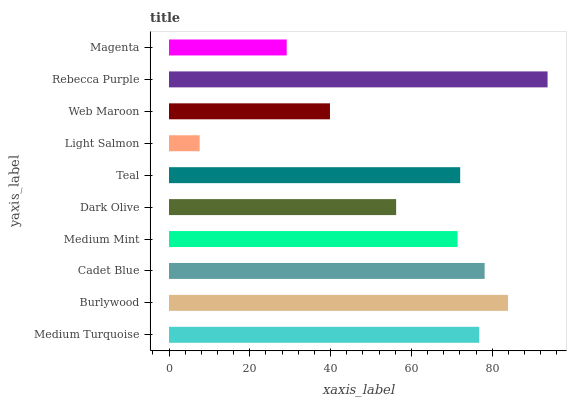Is Light Salmon the minimum?
Answer yes or no. Yes. Is Rebecca Purple the maximum?
Answer yes or no. Yes. Is Burlywood the minimum?
Answer yes or no. No. Is Burlywood the maximum?
Answer yes or no. No. Is Burlywood greater than Medium Turquoise?
Answer yes or no. Yes. Is Medium Turquoise less than Burlywood?
Answer yes or no. Yes. Is Medium Turquoise greater than Burlywood?
Answer yes or no. No. Is Burlywood less than Medium Turquoise?
Answer yes or no. No. Is Teal the high median?
Answer yes or no. Yes. Is Medium Mint the low median?
Answer yes or no. Yes. Is Cadet Blue the high median?
Answer yes or no. No. Is Dark Olive the low median?
Answer yes or no. No. 